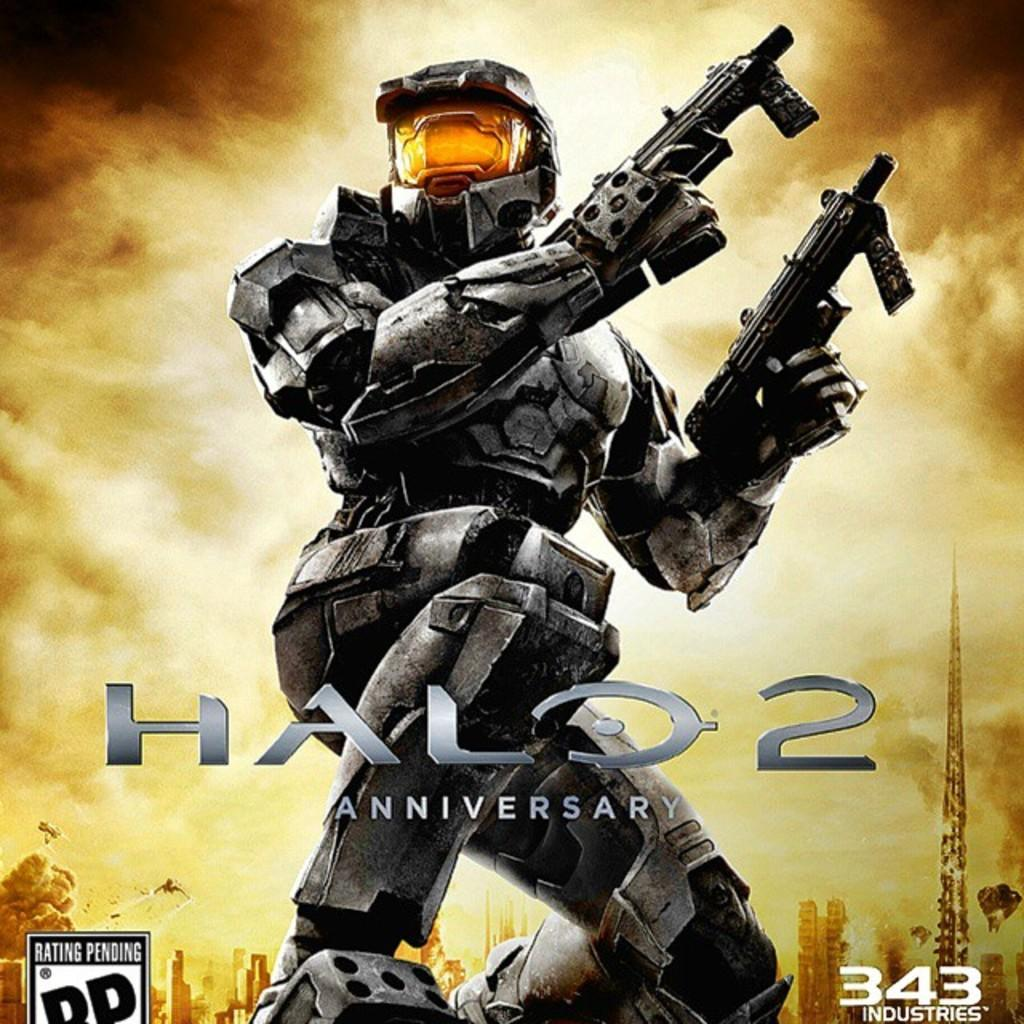<image>
Share a concise interpretation of the image provided. Video game cover for Halo 2 that shows a soldier with guns. 